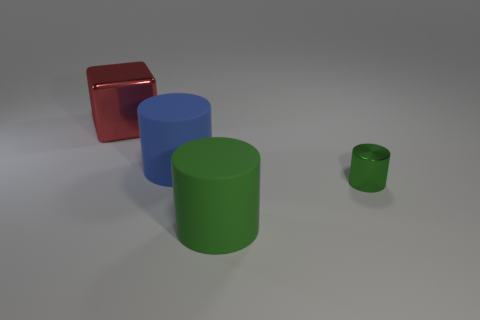Are there any other things that have the same size as the green metal cylinder?
Your answer should be very brief. No. Are there an equal number of rubber cylinders that are on the right side of the small green cylinder and green matte objects?
Provide a short and direct response. No. What shape is the thing that is both in front of the big cube and behind the tiny green cylinder?
Provide a succinct answer. Cylinder. There is another large matte object that is the same shape as the big blue rubber thing; what is its color?
Make the answer very short. Green. Are there any other things that have the same color as the large metal cube?
Provide a short and direct response. No. There is a big object that is in front of the metallic thing that is on the right side of the big thing in front of the tiny metal object; what is its shape?
Give a very brief answer. Cylinder. Do the green thing behind the big green matte cylinder and the green cylinder in front of the shiny cylinder have the same size?
Give a very brief answer. No. What number of tiny green cylinders are the same material as the blue cylinder?
Provide a succinct answer. 0. What number of large objects are behind the shiny object in front of the big red cube that is behind the small green thing?
Your answer should be very brief. 2. Is the shape of the large red thing the same as the big green matte object?
Provide a succinct answer. No. 